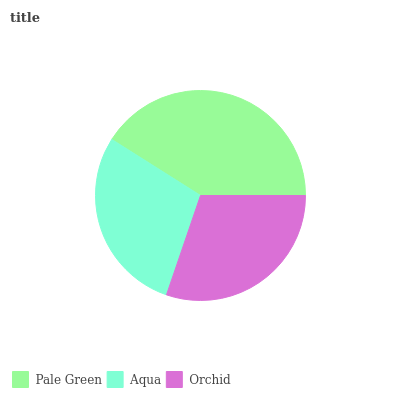Is Aqua the minimum?
Answer yes or no. Yes. Is Pale Green the maximum?
Answer yes or no. Yes. Is Orchid the minimum?
Answer yes or no. No. Is Orchid the maximum?
Answer yes or no. No. Is Orchid greater than Aqua?
Answer yes or no. Yes. Is Aqua less than Orchid?
Answer yes or no. Yes. Is Aqua greater than Orchid?
Answer yes or no. No. Is Orchid less than Aqua?
Answer yes or no. No. Is Orchid the high median?
Answer yes or no. Yes. Is Orchid the low median?
Answer yes or no. Yes. Is Pale Green the high median?
Answer yes or no. No. Is Pale Green the low median?
Answer yes or no. No. 